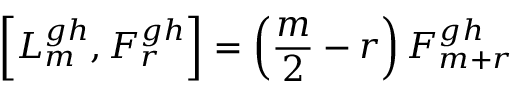<formula> <loc_0><loc_0><loc_500><loc_500>\left [ L _ { m } ^ { g h } , F _ { r } ^ { g h } \right ] = \left ( \frac { m } { 2 } - r \right ) F _ { m + r } ^ { g h }</formula> 